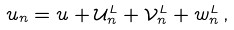<formula> <loc_0><loc_0><loc_500><loc_500>u _ { n } = u + { \mathcal { U } } _ { n } ^ { L } + { \mathcal { V } } _ { n } ^ { L } + w _ { n } ^ { L } \, ,</formula> 